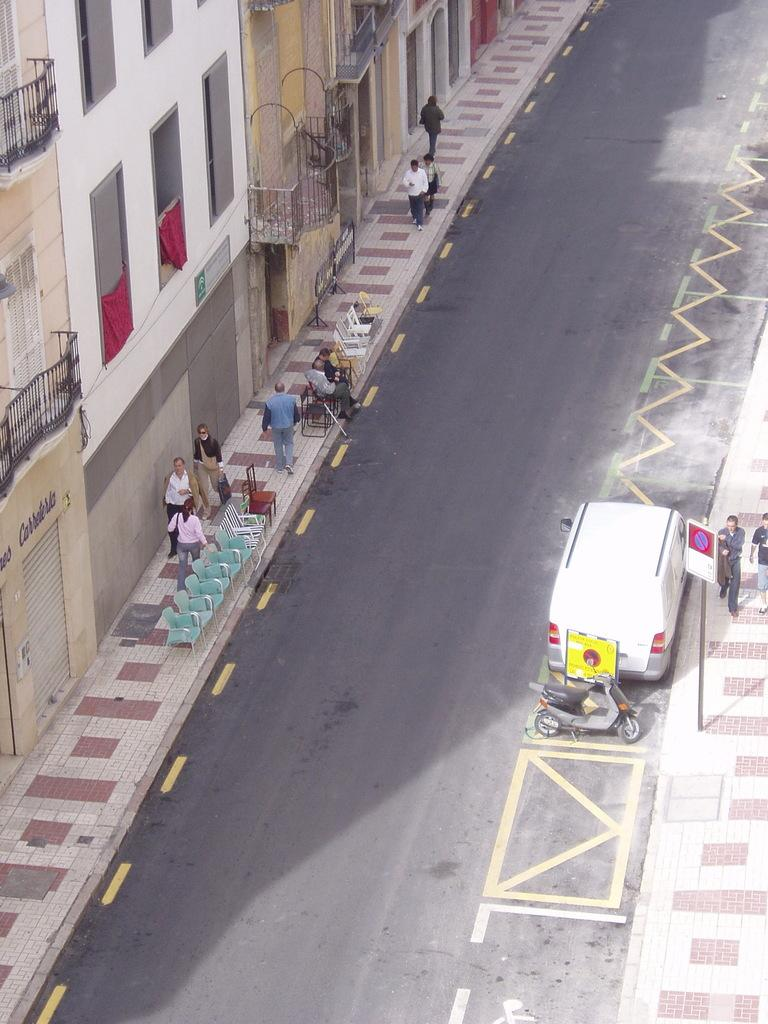What can be seen moving on the road in the image? There are vehicles on the road in the image. What is attached to a pole in the image? There is a board attached to a pole in the image. Who is present in the image besides the vehicles? There is a group of people in the image. What might the people be sitting on? There are chairs in the image, which the people might be sitting on. What type of structures can be seen in the background of the image? There are buildings in the image. What type of cherries are being desired by the group of people in the image? There are no cherries present in the image, and therefore no such desire can be observed. What is the back of the board attached to the pole in the image? The provided facts do not mention the back of the board, and it cannot be determined from the image. 